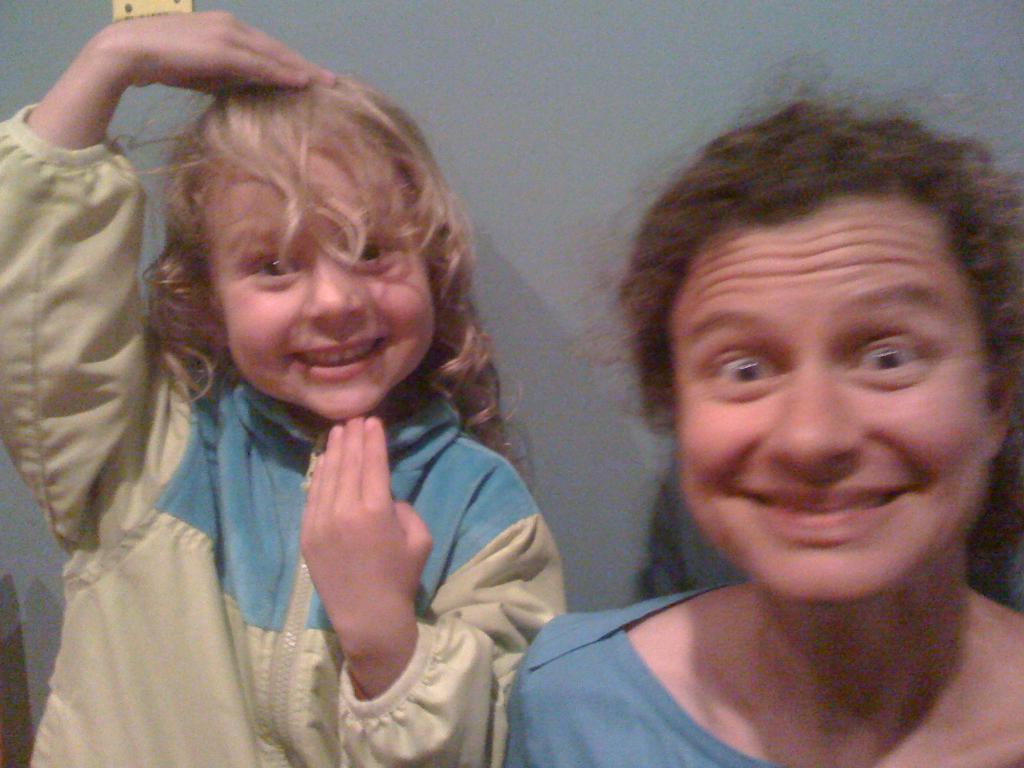Please provide a concise description of this image. In this image I can see a woman and a child smiling. I can see the grey colored background. 